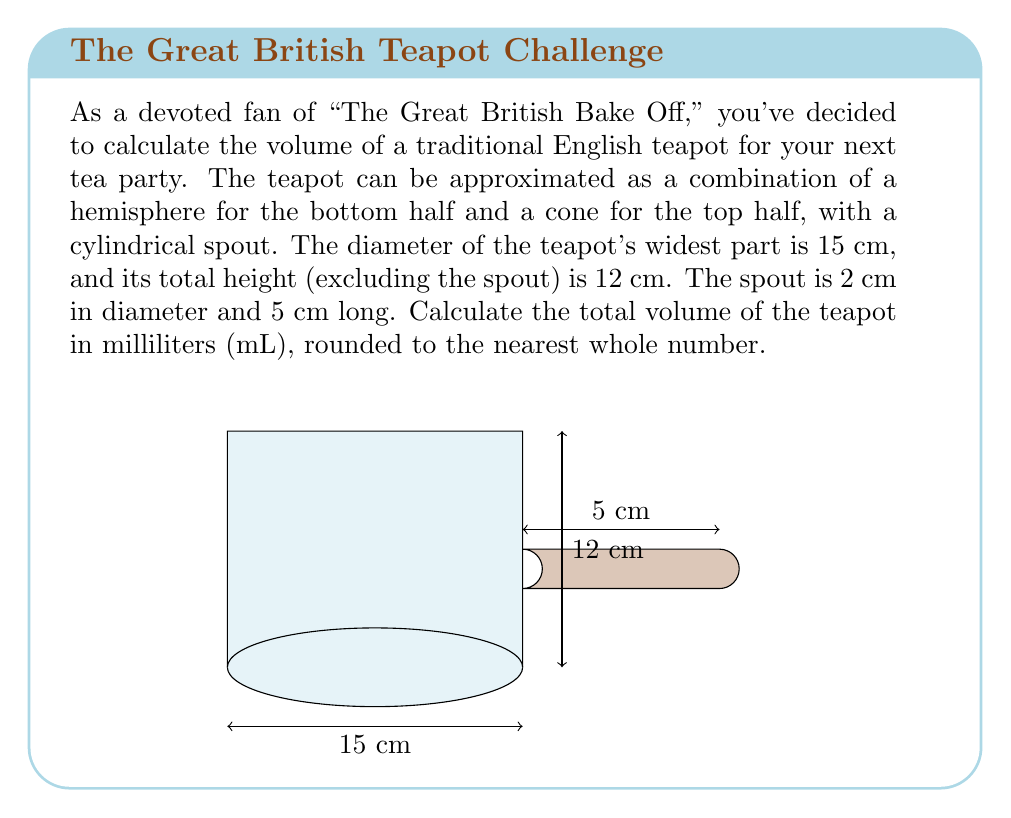Provide a solution to this math problem. Let's break this problem down into steps:

1) First, calculate the volume of the hemisphere:
   $$V_{hemisphere} = \frac{2}{3}\pi r^3$$
   where $r = 7.5$ cm (half of the 15 cm diameter)
   $$V_{hemisphere} = \frac{2}{3}\pi (7.5)^3 = 883.57 \text{ cm}^3$$

2) Next, calculate the volume of the cone:
   $$V_{cone} = \frac{1}{3}\pi r^2 h$$
   where $r = 7.5$ cm and $h = 6$ cm (half of the total height)
   $$V_{cone} = \frac{1}{3}\pi (7.5)^2 (6) = 353.43 \text{ cm}^3$$

3) Calculate the volume of the cylindrical spout:
   $$V_{spout} = \pi r^2 h$$
   where $r = 1$ cm (half of the 2 cm diameter) and $h = 5$ cm
   $$V_{spout} = \pi (1)^2 (5) = 15.71 \text{ cm}^3$$

4) Sum up all volumes:
   $$V_{total} = V_{hemisphere} + V_{cone} + V_{spout}$$
   $$V_{total} = 883.57 + 353.43 + 15.71 = 1252.71 \text{ cm}^3$$

5) Convert cubic centimeters to milliliters:
   1 cm³ = 1 mL, so no conversion is needed.

6) Round to the nearest whole number:
   1252.71 mL ≈ 1253 mL
Answer: 1253 mL 